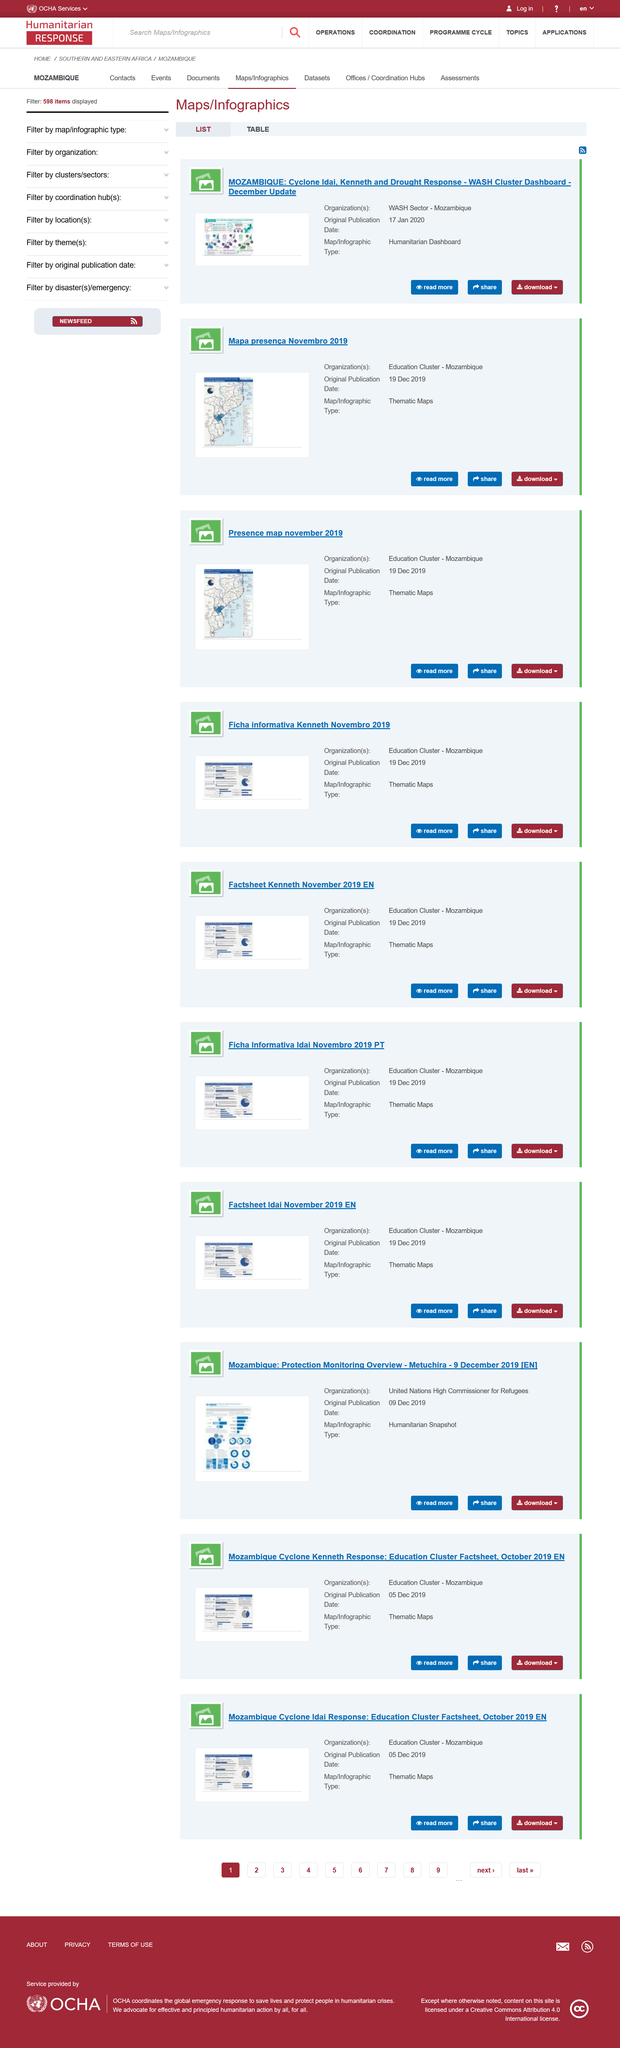Outline some significant characteristics in this image. The illustrations depict various aspects of Mozambique, and all of them are featured in the country. The Presence map was published in November 2019, and it was published on December 19, 2019. The Presence map of November 2019 is a thematic map, which displays information in a specific theme or category. 